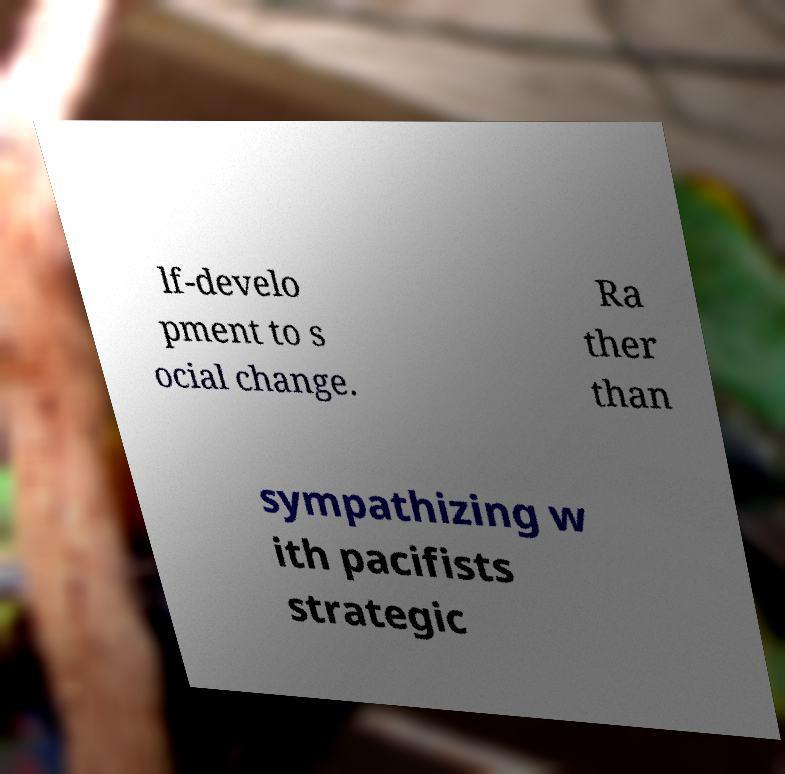I need the written content from this picture converted into text. Can you do that? lf-develo pment to s ocial change. Ra ther than sympathizing w ith pacifists strategic 